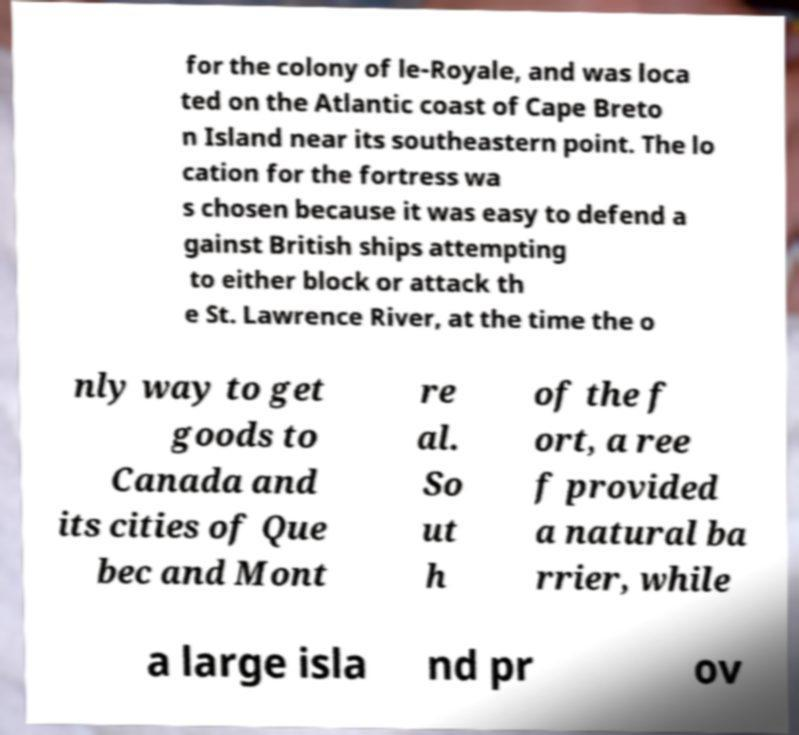Can you accurately transcribe the text from the provided image for me? for the colony of le-Royale, and was loca ted on the Atlantic coast of Cape Breto n Island near its southeastern point. The lo cation for the fortress wa s chosen because it was easy to defend a gainst British ships attempting to either block or attack th e St. Lawrence River, at the time the o nly way to get goods to Canada and its cities of Que bec and Mont re al. So ut h of the f ort, a ree f provided a natural ba rrier, while a large isla nd pr ov 